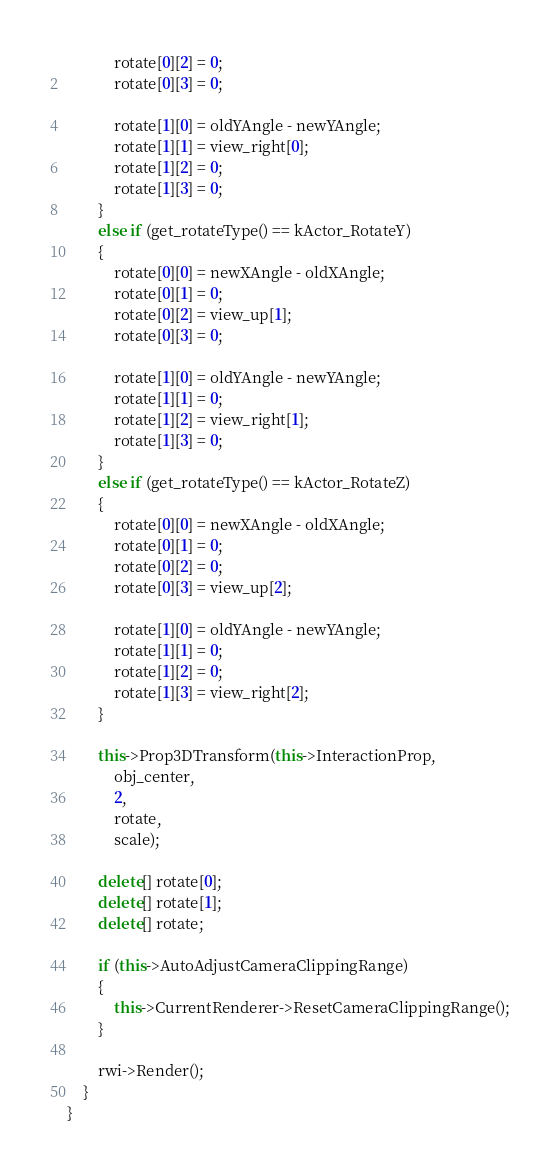Convert code to text. <code><loc_0><loc_0><loc_500><loc_500><_C++_>			rotate[0][2] = 0;
			rotate[0][3] = 0;

			rotate[1][0] = oldYAngle - newYAngle;
			rotate[1][1] = view_right[0];
			rotate[1][2] = 0;
			rotate[1][3] = 0;
		}
		else if (get_rotateType() == kActor_RotateY)
		{
			rotate[0][0] = newXAngle - oldXAngle;
			rotate[0][1] = 0;
			rotate[0][2] = view_up[1];
			rotate[0][3] = 0;

			rotate[1][0] = oldYAngle - newYAngle;
			rotate[1][1] = 0;
			rotate[1][2] = view_right[1];
			rotate[1][3] = 0;
		}
		else if (get_rotateType() == kActor_RotateZ)
		{
			rotate[0][0] = newXAngle - oldXAngle;
			rotate[0][1] = 0;
			rotate[0][2] = 0;
			rotate[0][3] = view_up[2];

			rotate[1][0] = oldYAngle - newYAngle;
			rotate[1][1] = 0;
			rotate[1][2] = 0;
			rotate[1][3] = view_right[2];
		}

		this->Prop3DTransform(this->InteractionProp,
			obj_center,
			2,
			rotate,
			scale);

		delete[] rotate[0];
		delete[] rotate[1];
		delete[] rotate;

		if (this->AutoAdjustCameraClippingRange)
		{
			this->CurrentRenderer->ResetCameraClippingRange();
		}

		rwi->Render();
	}
}

</code> 